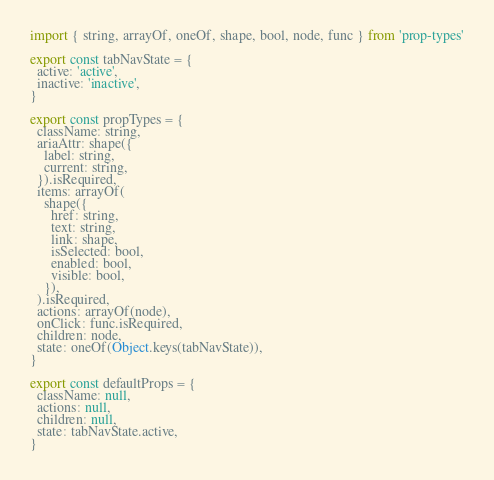Convert code to text. <code><loc_0><loc_0><loc_500><loc_500><_JavaScript_>import { string, arrayOf, oneOf, shape, bool, node, func } from 'prop-types'

export const tabNavState = {
  active: 'active',
  inactive: 'inactive',
}

export const propTypes = {
  className: string,
  ariaAttr: shape({
    label: string,
    current: string,
  }).isRequired,
  items: arrayOf(
    shape({
      href: string,
      text: string,
      link: shape,
      isSelected: bool,
      enabled: bool,
      visible: bool,
    }),
  ).isRequired,
  actions: arrayOf(node),
  onClick: func.isRequired,
  children: node,
  state: oneOf(Object.keys(tabNavState)),
}

export const defaultProps = {
  className: null,
  actions: null,
  children: null,
  state: tabNavState.active,
}
</code> 